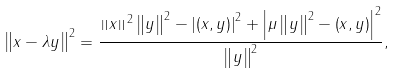Convert formula to latex. <formula><loc_0><loc_0><loc_500><loc_500>\left \| x - \lambda y \right \| ^ { 2 } = \frac { \left \| x \right \| ^ { 2 } \left \| y \right \| ^ { 2 } - \left | \left ( x , y \right ) \right | ^ { 2 } + \left | \mu \left \| y \right \| ^ { 2 } - \left ( x , y \right ) \right | ^ { 2 } } { \left \| y \right \| ^ { 2 } } ,</formula> 